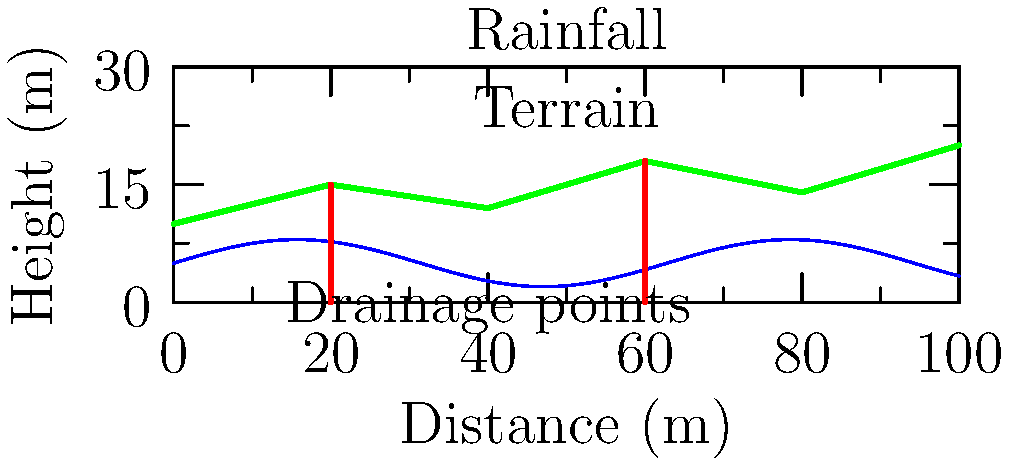Based on the diagram showing the terrain and rainfall patterns for a new park in Reading, at which distance should the main drainage point be placed to effectively manage water runoff? To determine the most effective location for the main drainage point, we need to consider both the terrain and rainfall patterns:

1. Analyze the terrain:
   - The terrain shows two low points at approximately 20m and 60m.
   - These low points are natural collection areas for water runoff.

2. Examine the rainfall pattern:
   - The rainfall pattern is represented by a sinusoidal curve.
   - The highest rainfall intensity occurs around 50-60m.

3. Consider the combination of terrain and rainfall:
   - The low point at 60m coincides with the area of highest rainfall intensity.
   - This makes it the most critical area for water accumulation.

4. Evaluate drainage effectiveness:
   - Placing the main drainage point at 60m would effectively manage water from both the high rainfall area and the natural low point in the terrain.
   - This location would also help prevent water accumulation in the lower areas of the park.

5. Consider local context:
   - As a resident of Reading familiar with outdoor spaces, you might recognize that effective drainage is crucial for maintaining usable park areas, especially during wet periods.

Therefore, the most effective location for the main drainage point would be at 60m distance.
Answer: 60m 